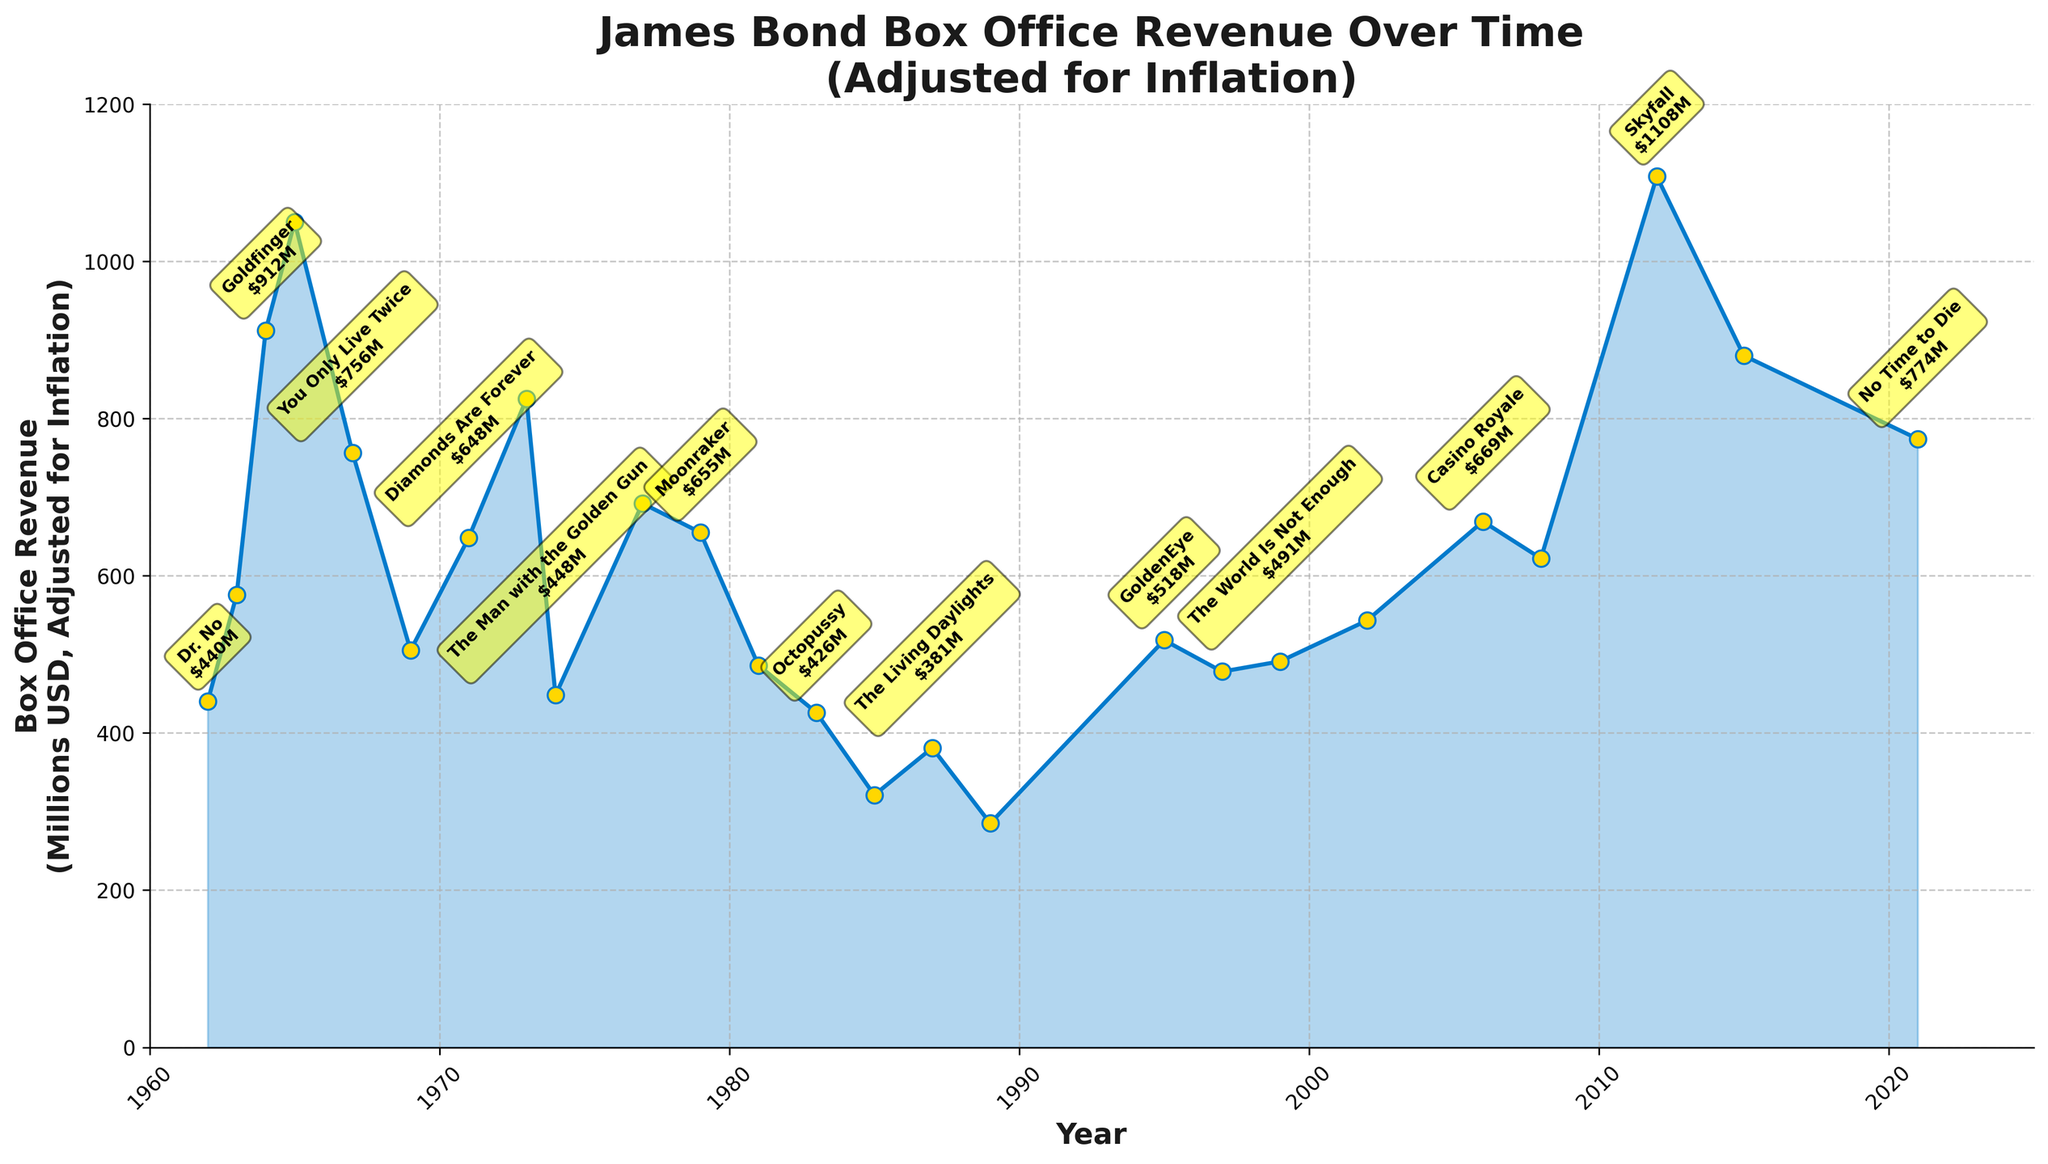What is the highest box office revenue shown in the chart? The highest box office revenue can be identified by looking for the peak point in the chart. The highest point corresponds to "Skyfall" released in 2012 with a revenue of 1108 million USD.
Answer: 1108 million USD Which James Bond film had the lowest box office revenue after adjusting for inflation? The lowest box office revenue can be found by identifying the lowest point on the chart. The film at this point is "Licence to Kill" released in 1989 with a revenue of 285 million USD.
Answer: Licence to Kill What is the difference in revenue between "Thunderball" (1965) and "Skyfall" (2012)? Find "Thunderball" (revenue: 1050 million USD) and "Skyfall" (revenue: 1108 million USD) on the chart. Subtract the revenue of "Thunderball" from that of "Skyfall" to get the difference: 1108 - 1050 = 58.
Answer: 58 million USD How many films released between 1962 and 2021 had a box office revenue higher than 700 million USD? Identify the films on the chart that have revenues higher than 700 million USD. These films are "Thunderball", "You Only Live Twice", "Live and Let Die", "Skyfall", and "Spectre". Count the number of these films to get the answer (5 films).
Answer: 5 Which film had a higher box office revenue: "Casino Royale" or "Quantum of Solace"? Locate "Casino Royale" (669 million USD) and "Quantum of Solace" (622 million USD) on the chart. Compare their revenue values. "Casino Royale" had higher revenue than "Quantum of Solace".
Answer: Casino Royale Which two consecutive films show the greatest drop in box office revenue? Examine the differences between the box office revenues of consecutive films on the chart. The greatest drop is between "Thunderball" (1050 million USD) and "You Only Live Twice" (756 million USD), with a difference of 294 million USD.
Answer: Thunderball to You Only Live Twice What is the average box office revenue of the first three James Bond films? Identify the revenues of the first three films: "Dr. No" (440 million USD), "From Russia with Love" (576 million USD), and "Goldfinger" (912 million USD). Add these values together and then divide by three to get the average: (440 + 576 + 912) / 3 = 642.67.
Answer: 642.67 million USD What trend can be observed between the box office revenues of films from 2002 to 2021? Observe the chart points from 2002 (Die Another Day) to 2021 (No Time to Die). The revenues show an increasing trend peaking at "Skyfall" and a slight decrease afterward with "Spectre" and "No Time to Die".
Answer: Increasing then slight decrease How does the revenue of "Moonraker" (1979) compare to the revenue of "The Spy Who Loved Me" (1977)? Find the values of "Moonraker" (655 million USD) and "The Spy Who Loved Me" (692 million USD) on the chart. Compare their revenues: "The Spy Who Loved Me" had a higher revenue than "Moonraker".
Answer: The Spy Who Loved Me had higher revenue What is the box office revenue of the film released in 1995? Locate the film released in 1995 ("GoldenEye") on the chart. The revenue is 518 million USD.
Answer: 518 million USD 